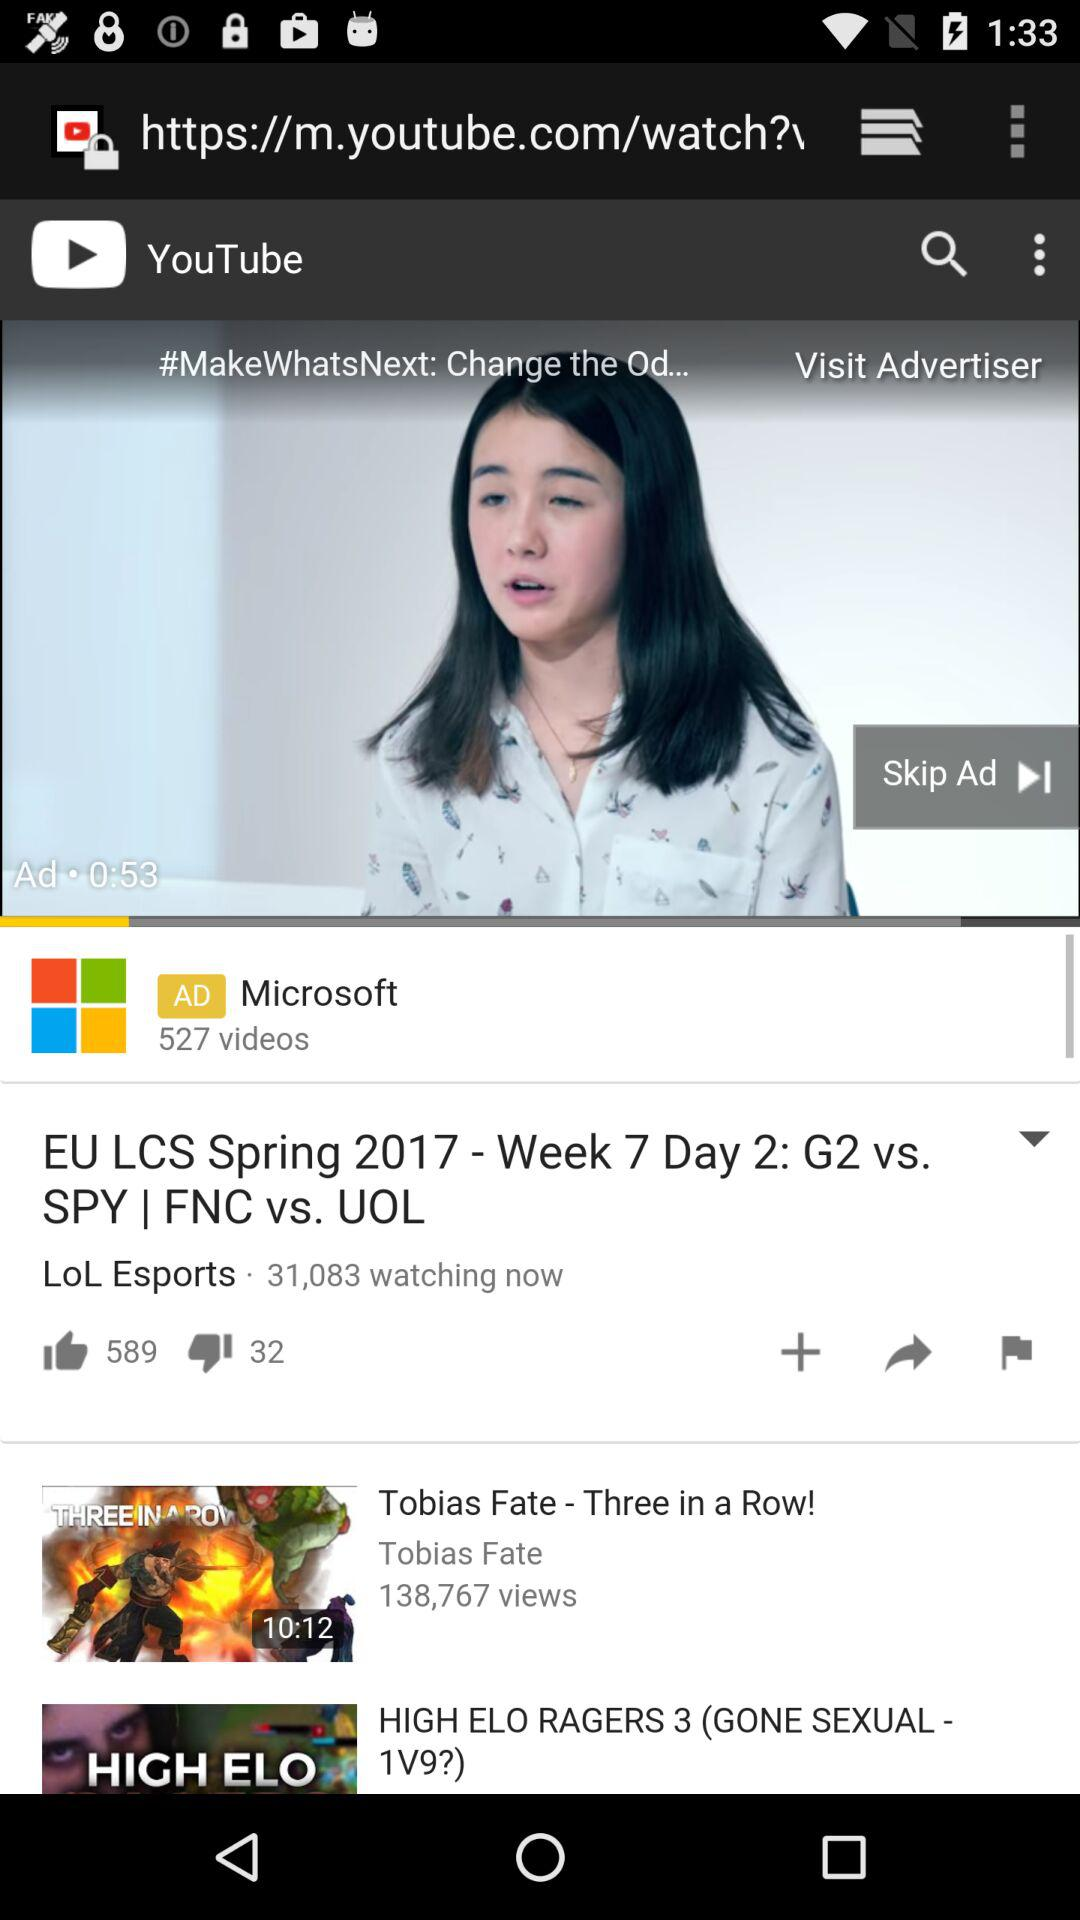On which channel is the video "EU LCS Spring 2017 - Week 7 Day 2: G2 vs. SPY | FNC vs. UOL" streaming? It is streaming on "LoL Esports". 